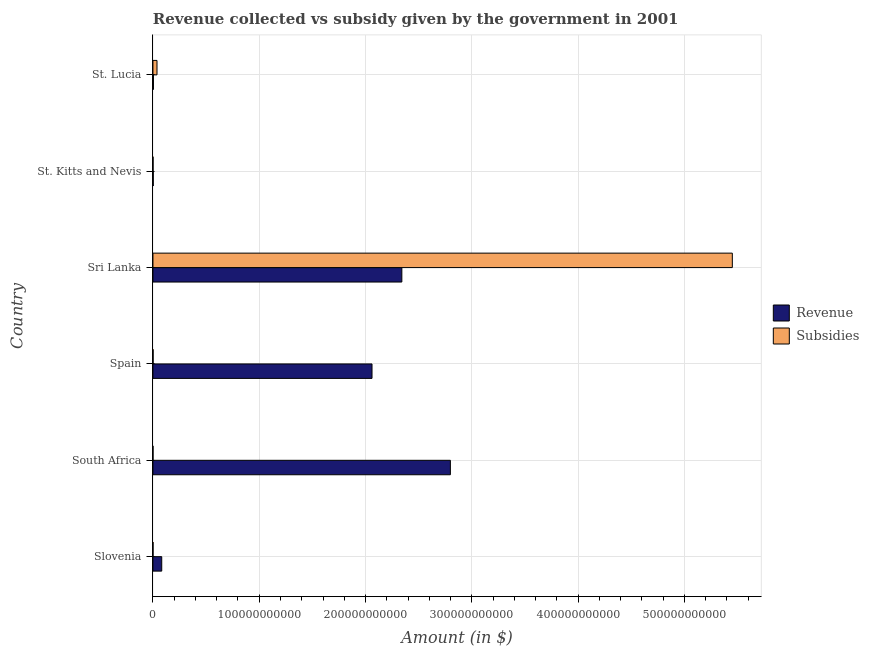How many groups of bars are there?
Your answer should be very brief. 6. How many bars are there on the 1st tick from the bottom?
Provide a succinct answer. 2. What is the label of the 1st group of bars from the top?
Your answer should be compact. St. Lucia. What is the amount of subsidies given in St. Lucia?
Keep it short and to the point. 3.81e+09. Across all countries, what is the maximum amount of revenue collected?
Offer a very short reply. 2.80e+11. Across all countries, what is the minimum amount of revenue collected?
Ensure brevity in your answer.  2.67e+08. In which country was the amount of subsidies given maximum?
Offer a terse response. Sri Lanka. In which country was the amount of revenue collected minimum?
Keep it short and to the point. St. Kitts and Nevis. What is the total amount of subsidies given in the graph?
Offer a terse response. 5.49e+11. What is the difference between the amount of subsidies given in Slovenia and that in St. Kitts and Nevis?
Ensure brevity in your answer.  -3.01e+07. What is the difference between the amount of revenue collected in Sri Lanka and the amount of subsidies given in South Africa?
Provide a succinct answer. 2.34e+11. What is the average amount of revenue collected per country?
Offer a terse response. 1.22e+11. What is the difference between the amount of subsidies given and amount of revenue collected in Spain?
Your response must be concise. -2.06e+11. What is the ratio of the amount of subsidies given in Slovenia to that in St. Lucia?
Ensure brevity in your answer.  0.02. Is the amount of revenue collected in Spain less than that in St. Lucia?
Keep it short and to the point. No. What is the difference between the highest and the second highest amount of revenue collected?
Offer a terse response. 4.57e+1. What is the difference between the highest and the lowest amount of subsidies given?
Provide a succinct answer. 5.45e+11. In how many countries, is the amount of revenue collected greater than the average amount of revenue collected taken over all countries?
Offer a very short reply. 3. What does the 2nd bar from the top in St. Kitts and Nevis represents?
Your response must be concise. Revenue. What does the 1st bar from the bottom in Slovenia represents?
Your response must be concise. Revenue. How many countries are there in the graph?
Your answer should be very brief. 6. What is the difference between two consecutive major ticks on the X-axis?
Your answer should be compact. 1.00e+11. Does the graph contain any zero values?
Give a very brief answer. No. What is the title of the graph?
Provide a short and direct response. Revenue collected vs subsidy given by the government in 2001. What is the label or title of the X-axis?
Provide a short and direct response. Amount (in $). What is the Amount (in $) of Revenue in Slovenia?
Give a very brief answer. 8.27e+09. What is the Amount (in $) in Subsidies in Slovenia?
Your answer should be very brief. 7.10e+07. What is the Amount (in $) of Revenue in South Africa?
Provide a short and direct response. 2.80e+11. What is the Amount (in $) in Subsidies in South Africa?
Offer a terse response. 4.97e+07. What is the Amount (in $) of Revenue in Spain?
Keep it short and to the point. 2.06e+11. What is the Amount (in $) of Subsidies in Spain?
Provide a succinct answer. 1.33e+08. What is the Amount (in $) of Revenue in Sri Lanka?
Make the answer very short. 2.34e+11. What is the Amount (in $) of Subsidies in Sri Lanka?
Provide a short and direct response. 5.45e+11. What is the Amount (in $) of Revenue in St. Kitts and Nevis?
Give a very brief answer. 2.67e+08. What is the Amount (in $) of Subsidies in St. Kitts and Nevis?
Your answer should be compact. 1.01e+08. What is the Amount (in $) of Revenue in St. Lucia?
Keep it short and to the point. 4.42e+08. What is the Amount (in $) of Subsidies in St. Lucia?
Offer a terse response. 3.81e+09. Across all countries, what is the maximum Amount (in $) of Revenue?
Keep it short and to the point. 2.80e+11. Across all countries, what is the maximum Amount (in $) of Subsidies?
Provide a short and direct response. 5.45e+11. Across all countries, what is the minimum Amount (in $) in Revenue?
Offer a very short reply. 2.67e+08. Across all countries, what is the minimum Amount (in $) in Subsidies?
Make the answer very short. 4.97e+07. What is the total Amount (in $) in Revenue in the graph?
Ensure brevity in your answer.  7.29e+11. What is the total Amount (in $) of Subsidies in the graph?
Offer a very short reply. 5.49e+11. What is the difference between the Amount (in $) of Revenue in Slovenia and that in South Africa?
Your answer should be very brief. -2.72e+11. What is the difference between the Amount (in $) in Subsidies in Slovenia and that in South Africa?
Keep it short and to the point. 2.13e+07. What is the difference between the Amount (in $) in Revenue in Slovenia and that in Spain?
Your answer should be very brief. -1.98e+11. What is the difference between the Amount (in $) in Subsidies in Slovenia and that in Spain?
Keep it short and to the point. -6.23e+07. What is the difference between the Amount (in $) in Revenue in Slovenia and that in Sri Lanka?
Your answer should be very brief. -2.26e+11. What is the difference between the Amount (in $) in Subsidies in Slovenia and that in Sri Lanka?
Offer a very short reply. -5.45e+11. What is the difference between the Amount (in $) of Revenue in Slovenia and that in St. Kitts and Nevis?
Offer a very short reply. 8.01e+09. What is the difference between the Amount (in $) in Subsidies in Slovenia and that in St. Kitts and Nevis?
Your response must be concise. -3.01e+07. What is the difference between the Amount (in $) in Revenue in Slovenia and that in St. Lucia?
Your answer should be very brief. 7.83e+09. What is the difference between the Amount (in $) of Subsidies in Slovenia and that in St. Lucia?
Your answer should be very brief. -3.74e+09. What is the difference between the Amount (in $) of Revenue in South Africa and that in Spain?
Provide a short and direct response. 7.37e+1. What is the difference between the Amount (in $) of Subsidies in South Africa and that in Spain?
Give a very brief answer. -8.36e+07. What is the difference between the Amount (in $) in Revenue in South Africa and that in Sri Lanka?
Offer a very short reply. 4.57e+1. What is the difference between the Amount (in $) in Subsidies in South Africa and that in Sri Lanka?
Keep it short and to the point. -5.45e+11. What is the difference between the Amount (in $) in Revenue in South Africa and that in St. Kitts and Nevis?
Offer a terse response. 2.80e+11. What is the difference between the Amount (in $) in Subsidies in South Africa and that in St. Kitts and Nevis?
Provide a short and direct response. -5.14e+07. What is the difference between the Amount (in $) in Revenue in South Africa and that in St. Lucia?
Your answer should be very brief. 2.79e+11. What is the difference between the Amount (in $) in Subsidies in South Africa and that in St. Lucia?
Ensure brevity in your answer.  -3.76e+09. What is the difference between the Amount (in $) of Revenue in Spain and that in Sri Lanka?
Offer a terse response. -2.81e+1. What is the difference between the Amount (in $) of Subsidies in Spain and that in Sri Lanka?
Your answer should be compact. -5.45e+11. What is the difference between the Amount (in $) of Revenue in Spain and that in St. Kitts and Nevis?
Make the answer very short. 2.06e+11. What is the difference between the Amount (in $) in Subsidies in Spain and that in St. Kitts and Nevis?
Provide a short and direct response. 3.22e+07. What is the difference between the Amount (in $) of Revenue in Spain and that in St. Lucia?
Keep it short and to the point. 2.06e+11. What is the difference between the Amount (in $) in Subsidies in Spain and that in St. Lucia?
Your answer should be compact. -3.68e+09. What is the difference between the Amount (in $) of Revenue in Sri Lanka and that in St. Kitts and Nevis?
Your answer should be compact. 2.34e+11. What is the difference between the Amount (in $) in Subsidies in Sri Lanka and that in St. Kitts and Nevis?
Give a very brief answer. 5.45e+11. What is the difference between the Amount (in $) of Revenue in Sri Lanka and that in St. Lucia?
Ensure brevity in your answer.  2.34e+11. What is the difference between the Amount (in $) of Subsidies in Sri Lanka and that in St. Lucia?
Provide a succinct answer. 5.41e+11. What is the difference between the Amount (in $) of Revenue in St. Kitts and Nevis and that in St. Lucia?
Provide a short and direct response. -1.75e+08. What is the difference between the Amount (in $) of Subsidies in St. Kitts and Nevis and that in St. Lucia?
Your answer should be very brief. -3.71e+09. What is the difference between the Amount (in $) in Revenue in Slovenia and the Amount (in $) in Subsidies in South Africa?
Keep it short and to the point. 8.22e+09. What is the difference between the Amount (in $) of Revenue in Slovenia and the Amount (in $) of Subsidies in Spain?
Your answer should be very brief. 8.14e+09. What is the difference between the Amount (in $) of Revenue in Slovenia and the Amount (in $) of Subsidies in Sri Lanka?
Offer a terse response. -5.37e+11. What is the difference between the Amount (in $) in Revenue in Slovenia and the Amount (in $) in Subsidies in St. Kitts and Nevis?
Offer a terse response. 8.17e+09. What is the difference between the Amount (in $) in Revenue in Slovenia and the Amount (in $) in Subsidies in St. Lucia?
Offer a terse response. 4.46e+09. What is the difference between the Amount (in $) of Revenue in South Africa and the Amount (in $) of Subsidies in Spain?
Provide a succinct answer. 2.80e+11. What is the difference between the Amount (in $) in Revenue in South Africa and the Amount (in $) in Subsidies in Sri Lanka?
Offer a terse response. -2.65e+11. What is the difference between the Amount (in $) in Revenue in South Africa and the Amount (in $) in Subsidies in St. Kitts and Nevis?
Provide a short and direct response. 2.80e+11. What is the difference between the Amount (in $) in Revenue in South Africa and the Amount (in $) in Subsidies in St. Lucia?
Give a very brief answer. 2.76e+11. What is the difference between the Amount (in $) in Revenue in Spain and the Amount (in $) in Subsidies in Sri Lanka?
Make the answer very short. -3.39e+11. What is the difference between the Amount (in $) in Revenue in Spain and the Amount (in $) in Subsidies in St. Kitts and Nevis?
Give a very brief answer. 2.06e+11. What is the difference between the Amount (in $) in Revenue in Spain and the Amount (in $) in Subsidies in St. Lucia?
Provide a short and direct response. 2.02e+11. What is the difference between the Amount (in $) of Revenue in Sri Lanka and the Amount (in $) of Subsidies in St. Kitts and Nevis?
Make the answer very short. 2.34e+11. What is the difference between the Amount (in $) of Revenue in Sri Lanka and the Amount (in $) of Subsidies in St. Lucia?
Offer a terse response. 2.30e+11. What is the difference between the Amount (in $) in Revenue in St. Kitts and Nevis and the Amount (in $) in Subsidies in St. Lucia?
Provide a short and direct response. -3.54e+09. What is the average Amount (in $) of Revenue per country?
Provide a succinct answer. 1.22e+11. What is the average Amount (in $) of Subsidies per country?
Your response must be concise. 9.16e+1. What is the difference between the Amount (in $) in Revenue and Amount (in $) in Subsidies in Slovenia?
Keep it short and to the point. 8.20e+09. What is the difference between the Amount (in $) in Revenue and Amount (in $) in Subsidies in South Africa?
Offer a very short reply. 2.80e+11. What is the difference between the Amount (in $) of Revenue and Amount (in $) of Subsidies in Spain?
Offer a terse response. 2.06e+11. What is the difference between the Amount (in $) of Revenue and Amount (in $) of Subsidies in Sri Lanka?
Provide a short and direct response. -3.11e+11. What is the difference between the Amount (in $) of Revenue and Amount (in $) of Subsidies in St. Kitts and Nevis?
Make the answer very short. 1.66e+08. What is the difference between the Amount (in $) in Revenue and Amount (in $) in Subsidies in St. Lucia?
Your answer should be very brief. -3.37e+09. What is the ratio of the Amount (in $) in Revenue in Slovenia to that in South Africa?
Provide a short and direct response. 0.03. What is the ratio of the Amount (in $) of Subsidies in Slovenia to that in South Africa?
Provide a short and direct response. 1.43. What is the ratio of the Amount (in $) of Revenue in Slovenia to that in Spain?
Your response must be concise. 0.04. What is the ratio of the Amount (in $) in Subsidies in Slovenia to that in Spain?
Your response must be concise. 0.53. What is the ratio of the Amount (in $) in Revenue in Slovenia to that in Sri Lanka?
Offer a terse response. 0.04. What is the ratio of the Amount (in $) of Revenue in Slovenia to that in St. Kitts and Nevis?
Offer a very short reply. 30.95. What is the ratio of the Amount (in $) of Subsidies in Slovenia to that in St. Kitts and Nevis?
Keep it short and to the point. 0.7. What is the ratio of the Amount (in $) in Revenue in Slovenia to that in St. Lucia?
Your answer should be very brief. 18.7. What is the ratio of the Amount (in $) in Subsidies in Slovenia to that in St. Lucia?
Your answer should be compact. 0.02. What is the ratio of the Amount (in $) of Revenue in South Africa to that in Spain?
Your answer should be very brief. 1.36. What is the ratio of the Amount (in $) of Subsidies in South Africa to that in Spain?
Offer a terse response. 0.37. What is the ratio of the Amount (in $) of Revenue in South Africa to that in Sri Lanka?
Provide a succinct answer. 1.2. What is the ratio of the Amount (in $) in Subsidies in South Africa to that in Sri Lanka?
Keep it short and to the point. 0. What is the ratio of the Amount (in $) in Revenue in South Africa to that in St. Kitts and Nevis?
Your answer should be compact. 1046.95. What is the ratio of the Amount (in $) in Subsidies in South Africa to that in St. Kitts and Nevis?
Give a very brief answer. 0.49. What is the ratio of the Amount (in $) in Revenue in South Africa to that in St. Lucia?
Offer a very short reply. 632.71. What is the ratio of the Amount (in $) in Subsidies in South Africa to that in St. Lucia?
Your response must be concise. 0.01. What is the ratio of the Amount (in $) of Revenue in Spain to that in Sri Lanka?
Your response must be concise. 0.88. What is the ratio of the Amount (in $) in Revenue in Spain to that in St. Kitts and Nevis?
Your answer should be very brief. 771.11. What is the ratio of the Amount (in $) of Subsidies in Spain to that in St. Kitts and Nevis?
Ensure brevity in your answer.  1.32. What is the ratio of the Amount (in $) in Revenue in Spain to that in St. Lucia?
Your answer should be compact. 466.01. What is the ratio of the Amount (in $) in Subsidies in Spain to that in St. Lucia?
Provide a short and direct response. 0.04. What is the ratio of the Amount (in $) in Revenue in Sri Lanka to that in St. Kitts and Nevis?
Provide a short and direct response. 876.13. What is the ratio of the Amount (in $) of Subsidies in Sri Lanka to that in St. Kitts and Nevis?
Provide a short and direct response. 5389.79. What is the ratio of the Amount (in $) in Revenue in Sri Lanka to that in St. Lucia?
Offer a very short reply. 529.48. What is the ratio of the Amount (in $) of Subsidies in Sri Lanka to that in St. Lucia?
Your answer should be very brief. 143.01. What is the ratio of the Amount (in $) of Revenue in St. Kitts and Nevis to that in St. Lucia?
Make the answer very short. 0.6. What is the ratio of the Amount (in $) of Subsidies in St. Kitts and Nevis to that in St. Lucia?
Your response must be concise. 0.03. What is the difference between the highest and the second highest Amount (in $) in Revenue?
Offer a very short reply. 4.57e+1. What is the difference between the highest and the second highest Amount (in $) of Subsidies?
Provide a short and direct response. 5.41e+11. What is the difference between the highest and the lowest Amount (in $) of Revenue?
Offer a terse response. 2.80e+11. What is the difference between the highest and the lowest Amount (in $) in Subsidies?
Your answer should be compact. 5.45e+11. 